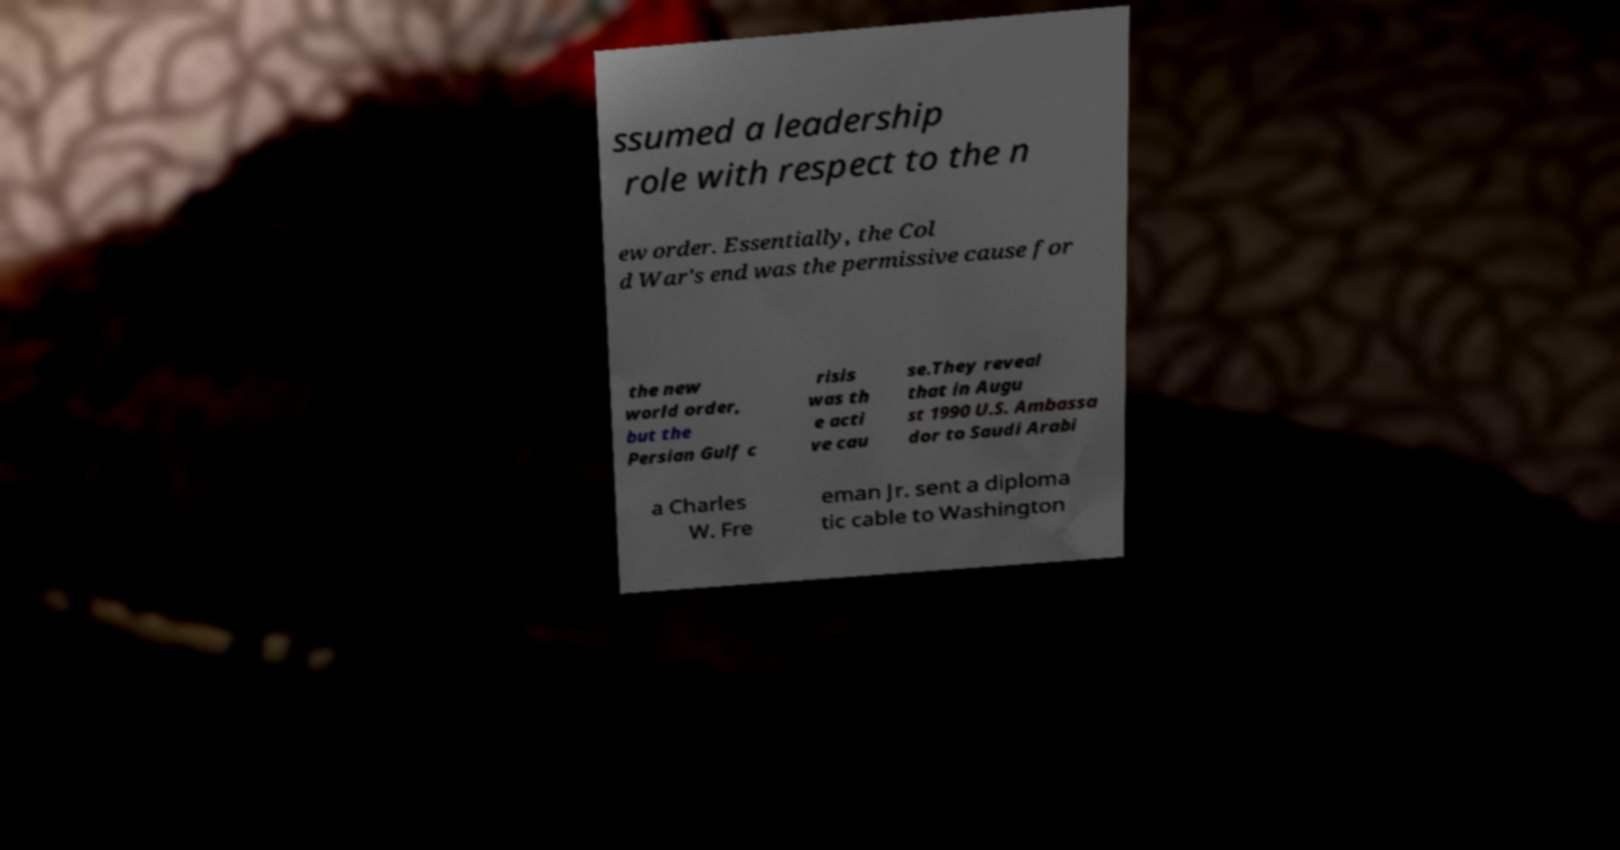Can you accurately transcribe the text from the provided image for me? ssumed a leadership role with respect to the n ew order. Essentially, the Col d War's end was the permissive cause for the new world order, but the Persian Gulf c risis was th e acti ve cau se.They reveal that in Augu st 1990 U.S. Ambassa dor to Saudi Arabi a Charles W. Fre eman Jr. sent a diploma tic cable to Washington 